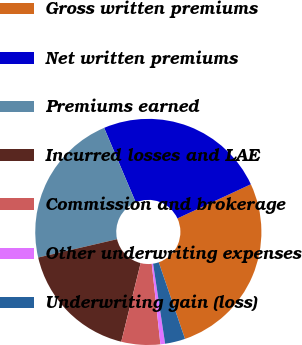<chart> <loc_0><loc_0><loc_500><loc_500><pie_chart><fcel>Gross written premiums<fcel>Net written premiums<fcel>Premiums earned<fcel>Incurred losses and LAE<fcel>Commission and brokerage<fcel>Other underwriting expenses<fcel>Underwriting gain (loss)<nl><fcel>26.67%<fcel>24.46%<fcel>22.24%<fcel>17.52%<fcel>5.55%<fcel>0.67%<fcel>2.88%<nl></chart> 